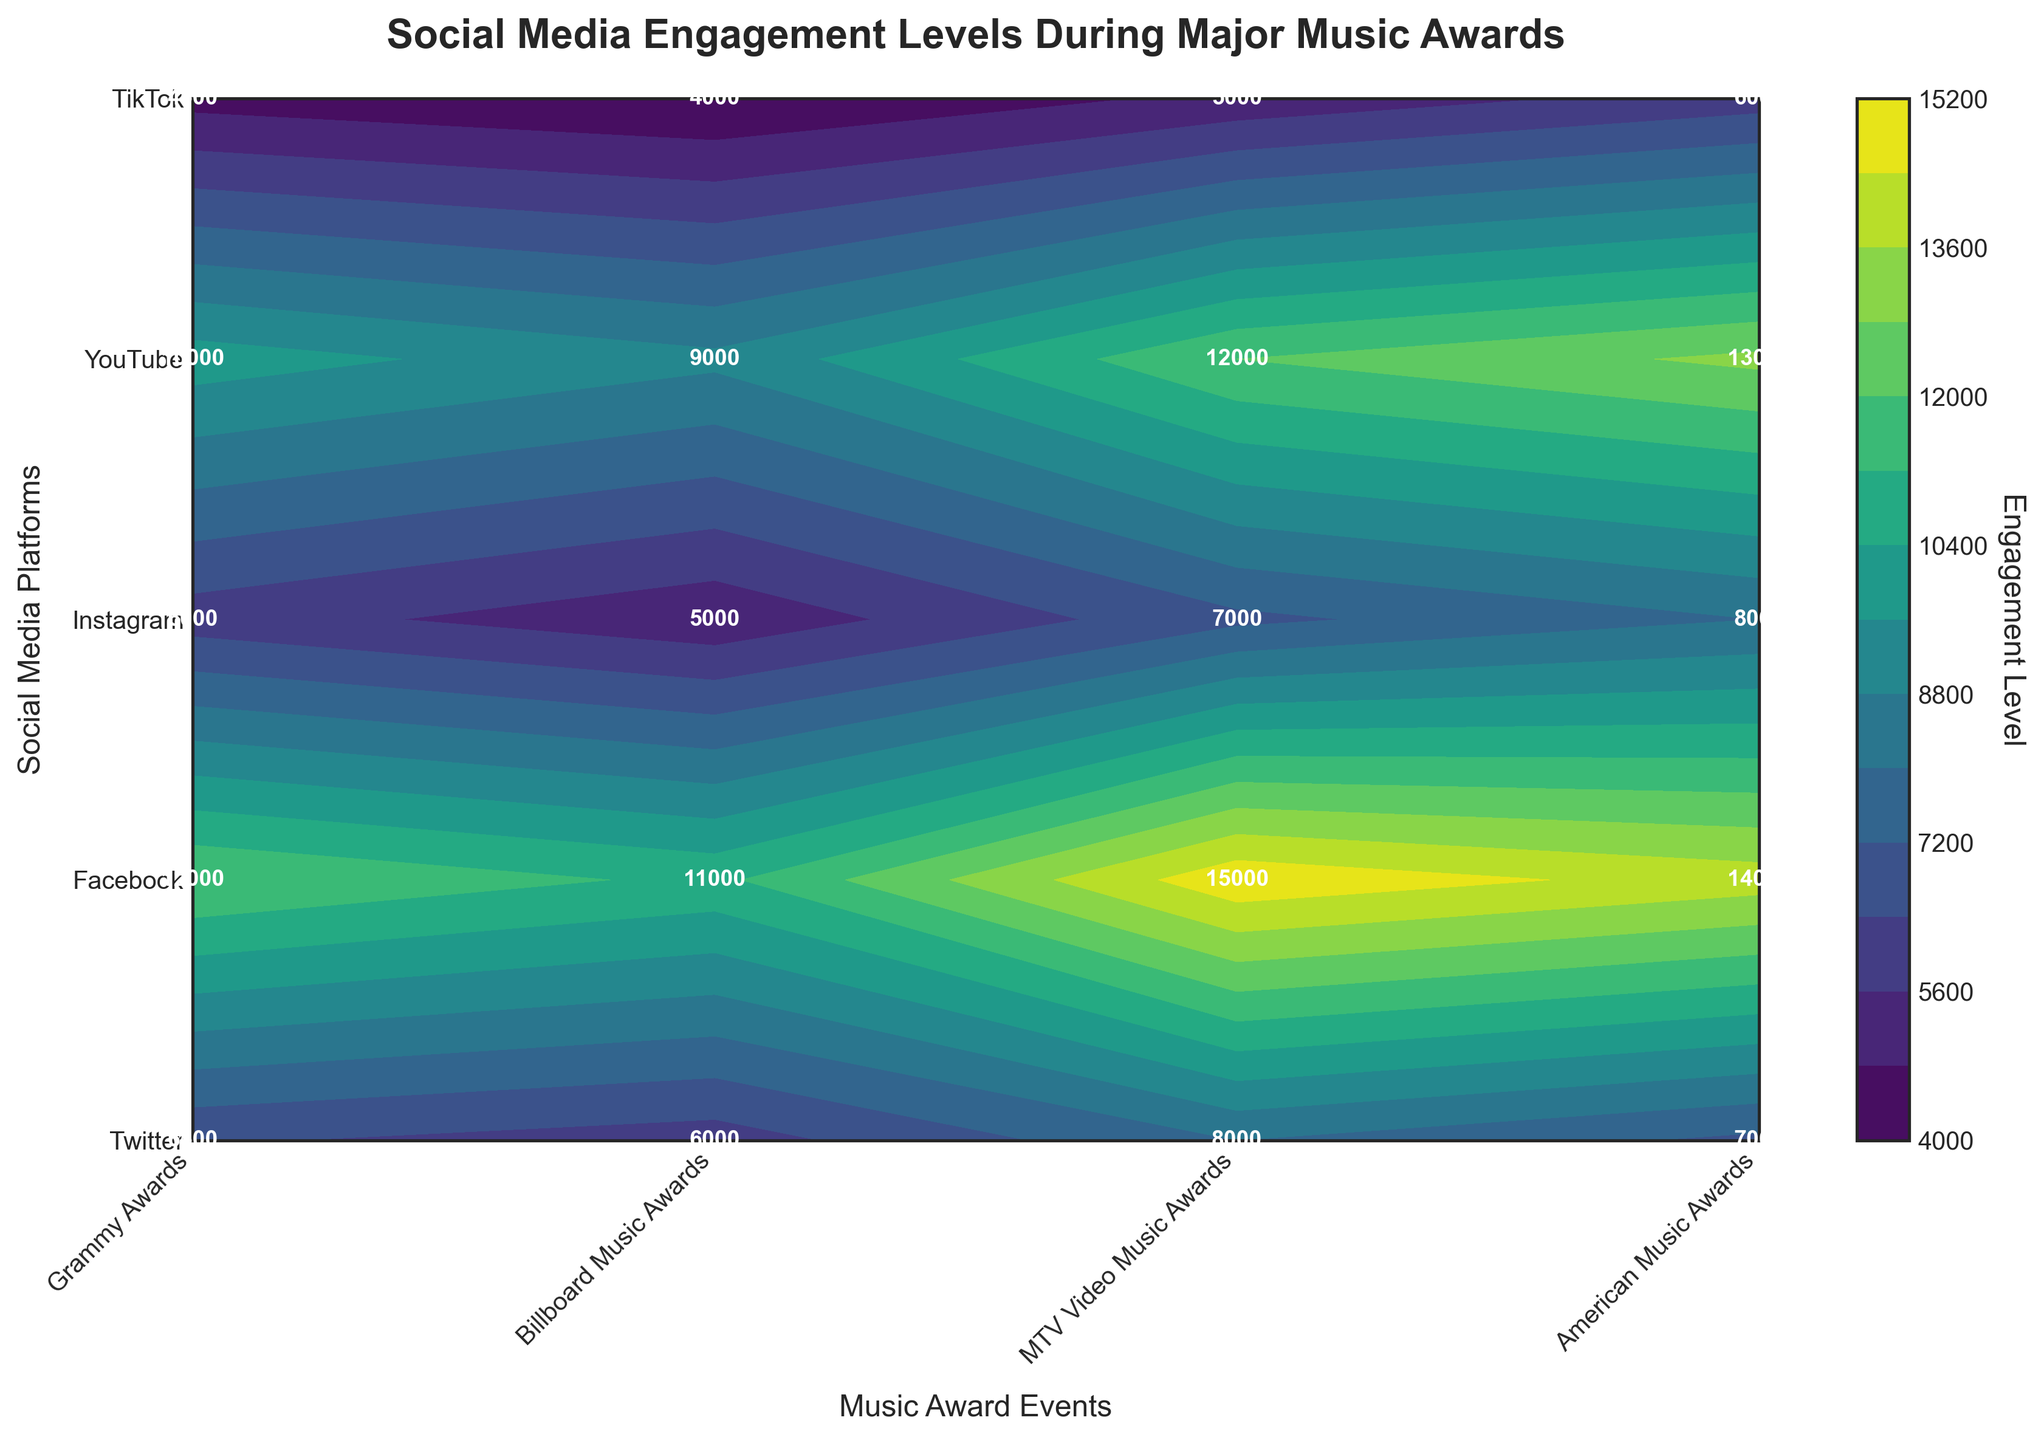What is the title of the plot? The title of a plot is usually located at the top of the figure, often in larger and bold font. Here, the title in bold font at the top reads "Social Media Engagement Levels During Major Music Awards."
Answer: Social Media Engagement Levels During Major Music Awards Which social media platform has the highest engagement level for the Grammy Awards? Look at the label where the Grammy Awards intersect with the social media platforms. The highest number written is 15000 under Instagram
Answer: Instagram Compare the engagement levels between Facebook and YouTube for the MTV Video Music Awards. Which one is higher? Find the row where Facebook intersects with the MTV Video Music Awards, which shows 7000, and the row for YouTube, which shows 6000. Since 7000 is greater than 6000, Facebook has a higher engagement level.
Answer: Facebook What is the average engagement level across all platforms for the Billboard Music Awards? Sum the engagement levels for all platforms under Billboard Music Awards: 9000 (Twitter) + 6000 (Facebook) + 11000 (Instagram) + 4000 (YouTube) + 5000 (TikTok) = 35000. Divide this sum by the number of platforms (5): 35000 / 5 = 7000
Answer: 7000 Which event has the lowest engagement level for YouTube? Find the values under YouTube for each event: Grammy Awards (5000), Billboard Music Awards (4000), MTV Video Music Awards (6000), American Music Awards (4500). The lowest value is 4000 for the Billboard Music Awards.
Answer: Billboard Music Awards How many data points are labeled in the figure? Count the engagement level numbers written inside the contour plot cells. There are 20 numbers (one per platform and event combination).
Answer: 20 What is the difference in engagement levels between Instagram and TikTok for the American Music Awards? Under the American Music Awards, find Instagram (12000) and TikTok (6000). Subtract TikTok's value from Instagram's: 12000 - 6000 = 6000
Answer: 6000 What are the x-axis and y-axis labels? The x-axis label typically appears below the horizontal axis, and the y-axis label appears alongside the vertical axis. Here, the x-axis label is "Music Award Events" and the y-axis label is "Social Media Platforms."
Answer: Music Award Events; Social Media Platforms 